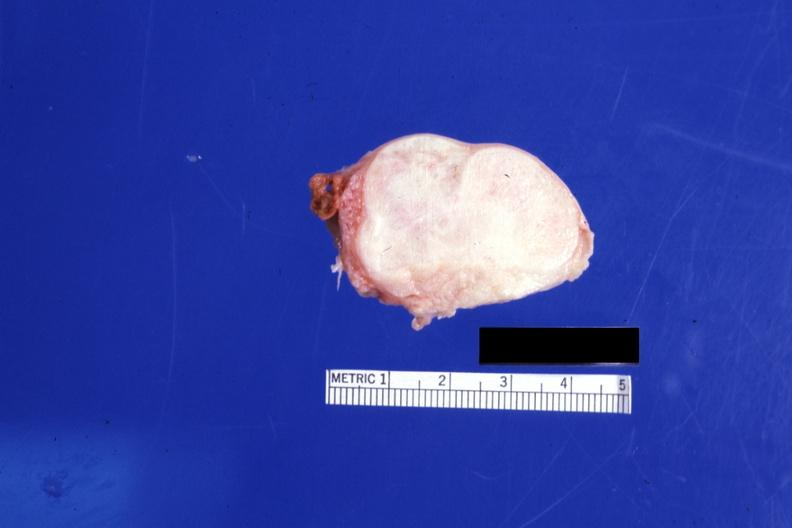s stillborn cord around neck present?
Answer the question using a single word or phrase. No 